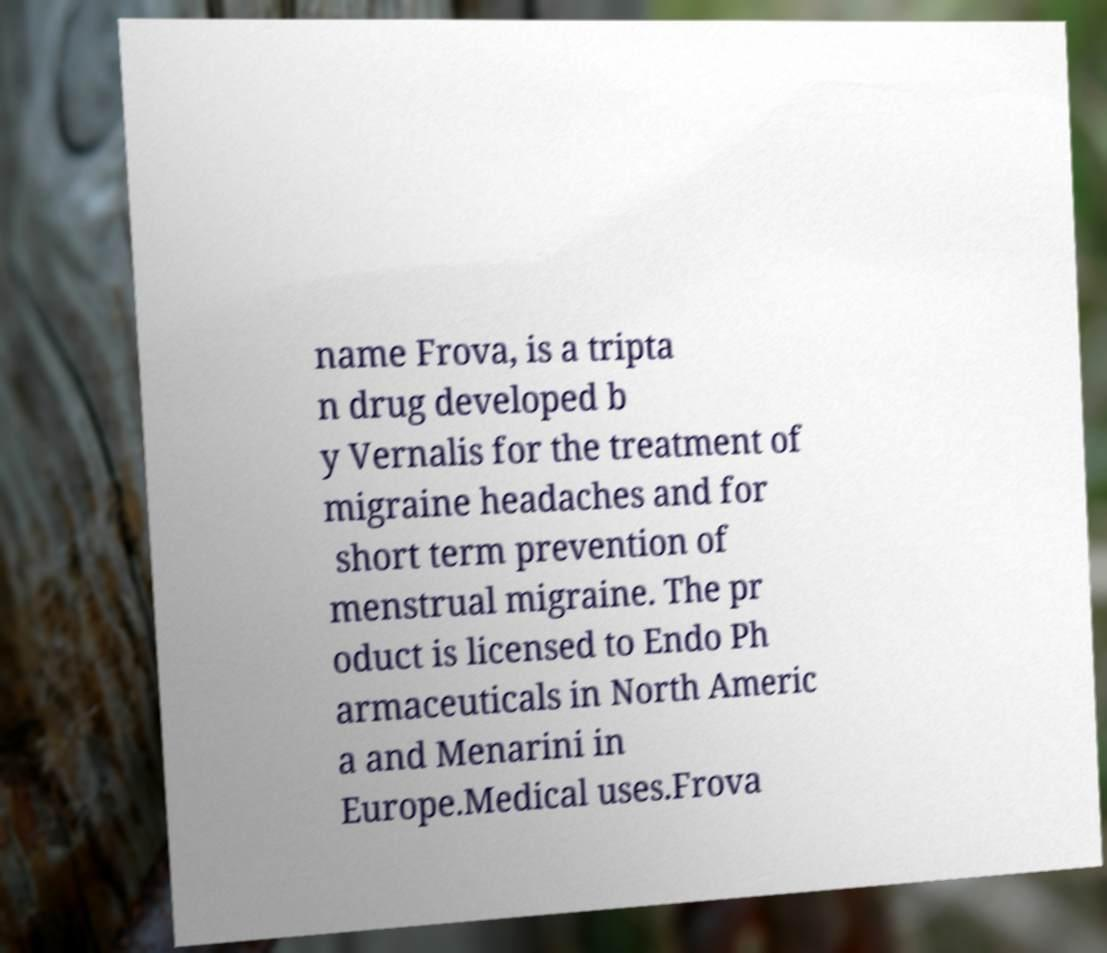For documentation purposes, I need the text within this image transcribed. Could you provide that? name Frova, is a tripta n drug developed b y Vernalis for the treatment of migraine headaches and for short term prevention of menstrual migraine. The pr oduct is licensed to Endo Ph armaceuticals in North Americ a and Menarini in Europe.Medical uses.Frova 